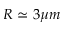Convert formula to latex. <formula><loc_0><loc_0><loc_500><loc_500>R \simeq 3 \mu m</formula> 